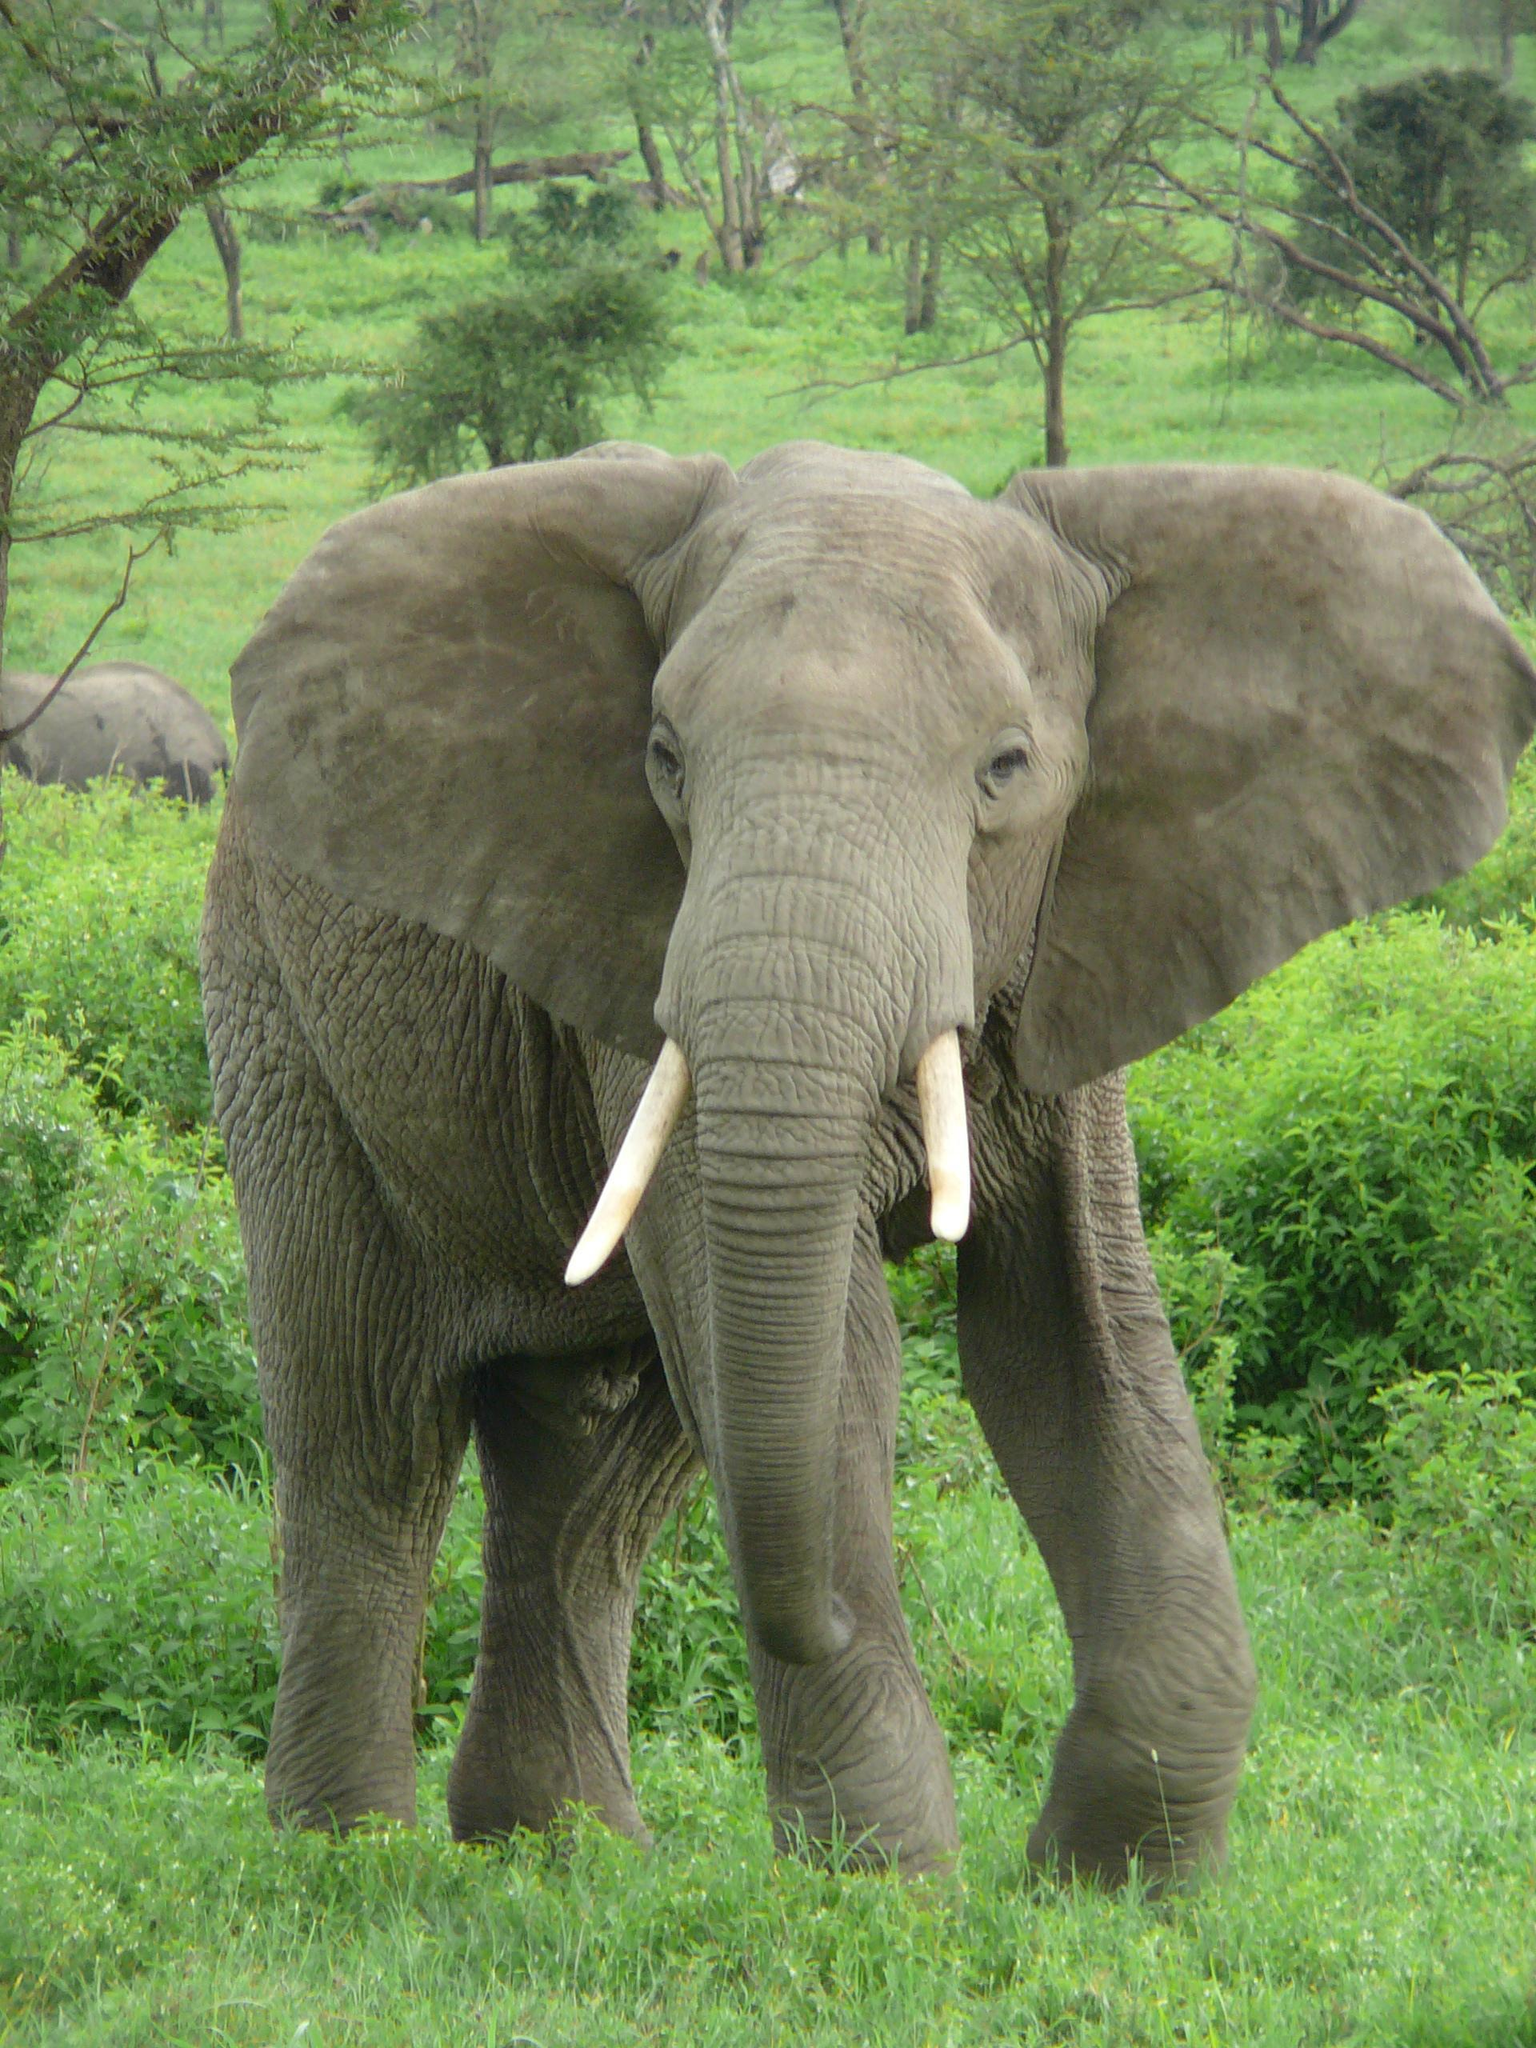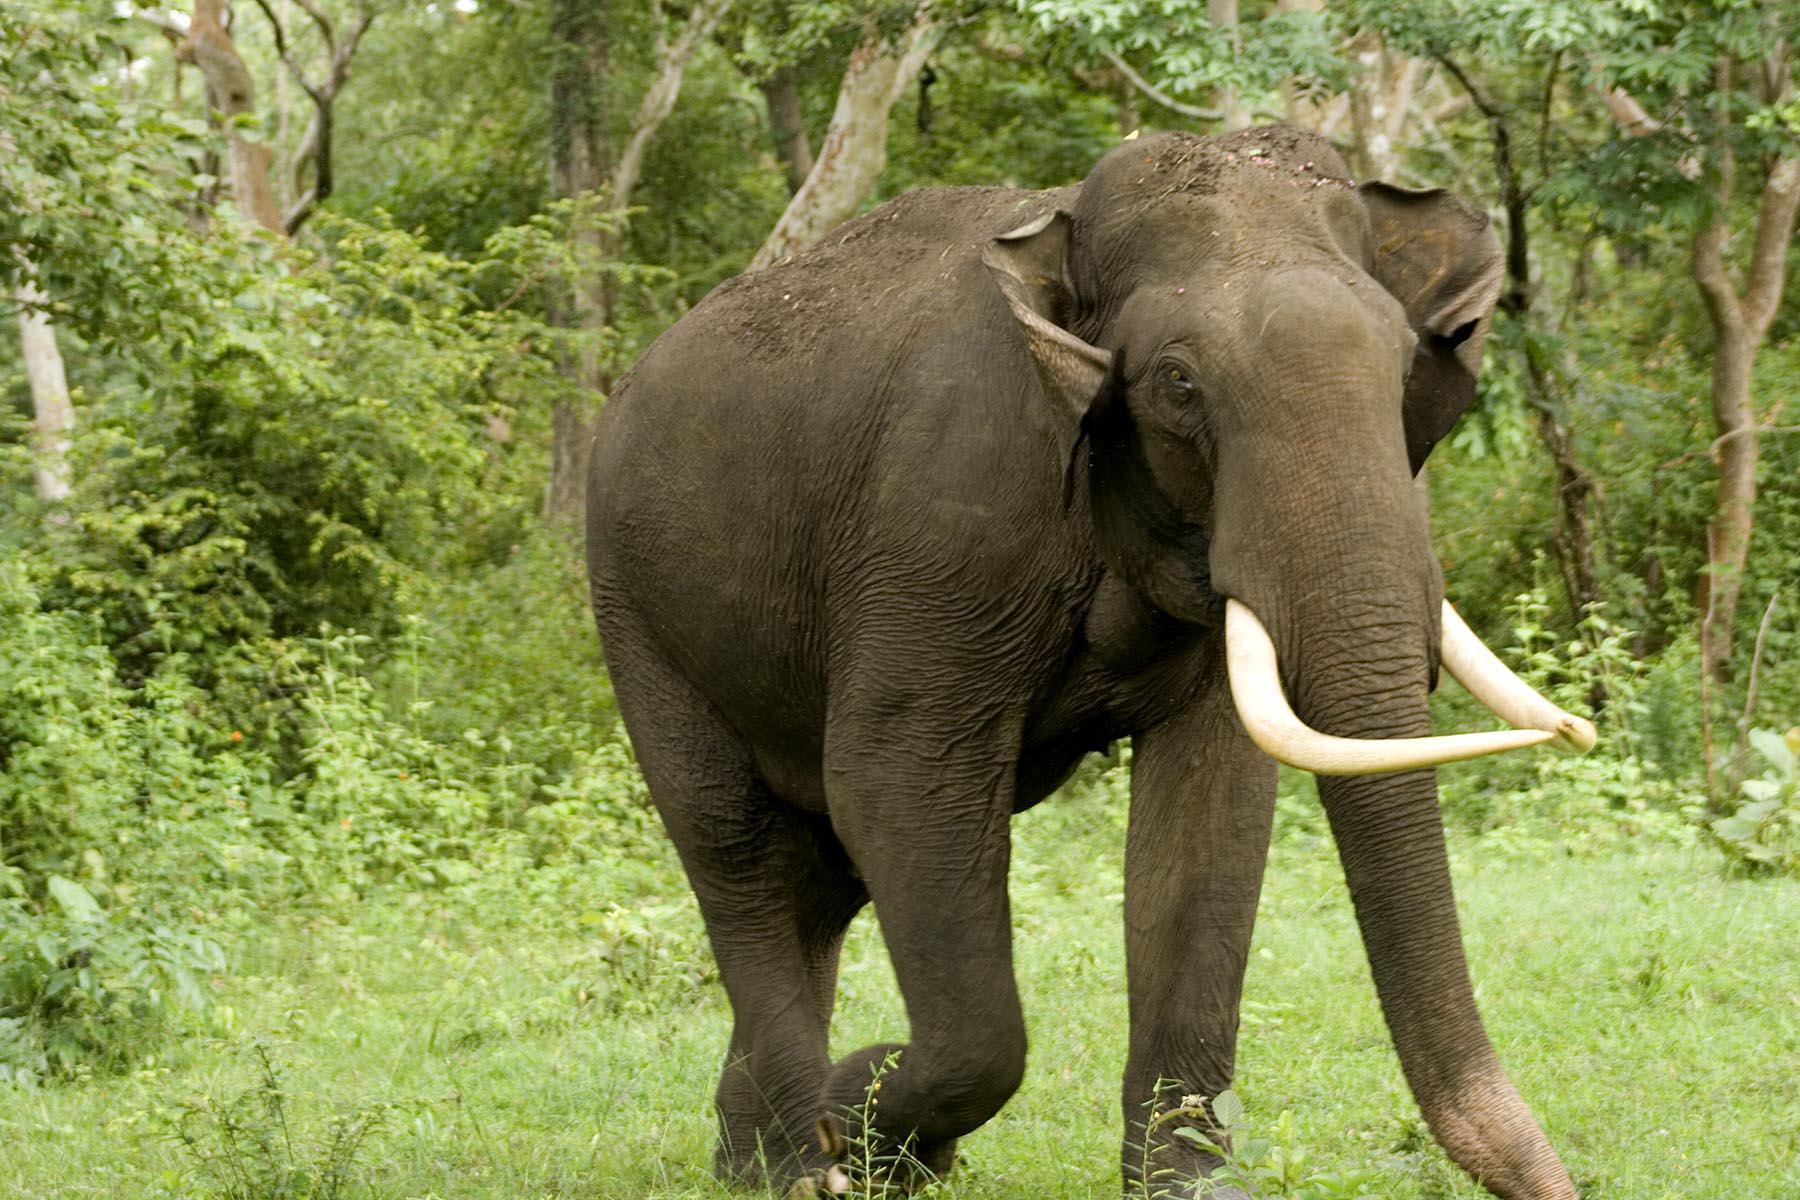The first image is the image on the left, the second image is the image on the right. For the images displayed, is the sentence "There are more animals in the image on the right." factually correct? Answer yes or no. No. 